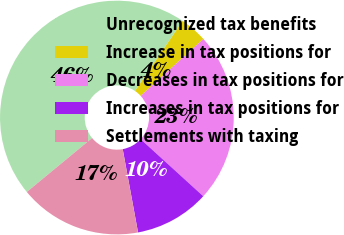Convert chart to OTSL. <chart><loc_0><loc_0><loc_500><loc_500><pie_chart><fcel>Unrecognized tax benefits<fcel>Increase in tax positions for<fcel>Decreases in tax positions for<fcel>Increases in tax positions for<fcel>Settlements with taxing<nl><fcel>45.5%<fcel>3.76%<fcel>23.49%<fcel>10.34%<fcel>16.91%<nl></chart> 